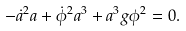Convert formula to latex. <formula><loc_0><loc_0><loc_500><loc_500>- { \dot { a } ^ { 2 } } { a } + { \dot { \phi } ^ { 2 } } { a ^ { 3 } } + a ^ { 3 } g \phi ^ { 2 } = 0 .</formula> 